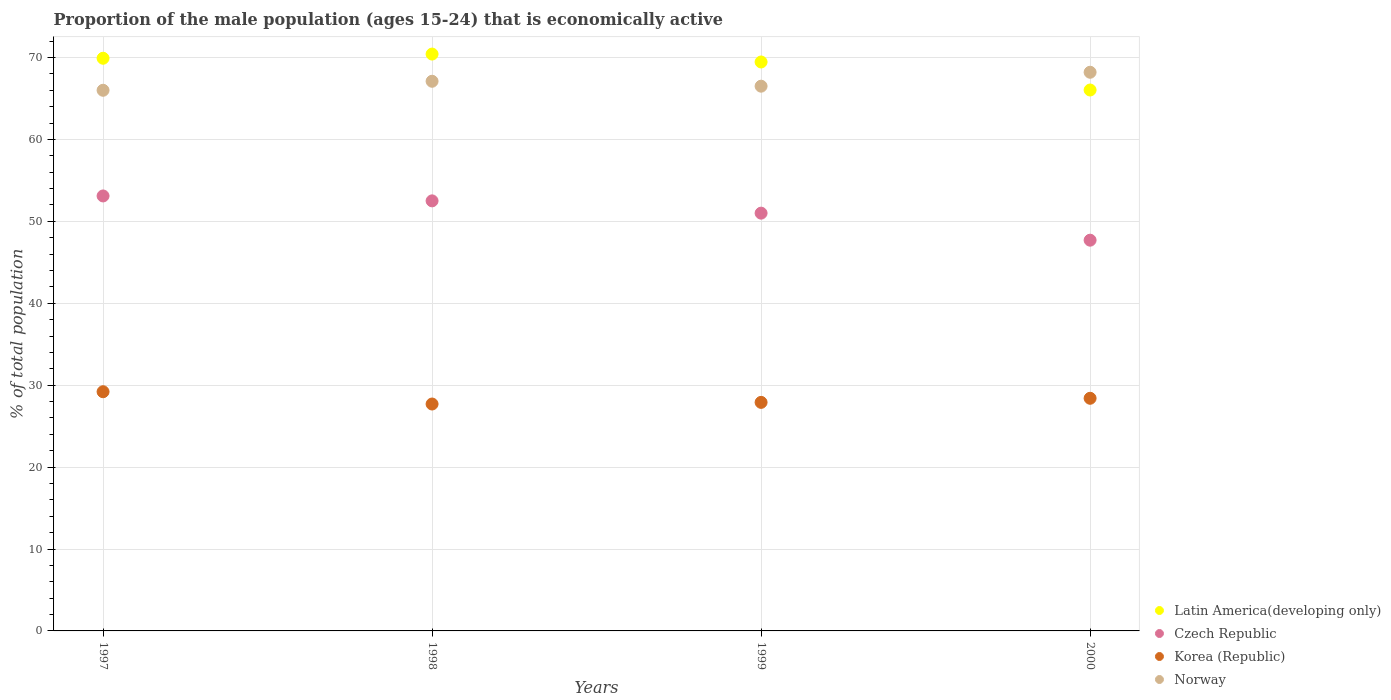What is the proportion of the male population that is economically active in Korea (Republic) in 1997?
Your response must be concise. 29.2. Across all years, what is the maximum proportion of the male population that is economically active in Latin America(developing only)?
Provide a succinct answer. 70.42. Across all years, what is the minimum proportion of the male population that is economically active in Latin America(developing only)?
Give a very brief answer. 66.03. What is the total proportion of the male population that is economically active in Norway in the graph?
Your answer should be compact. 267.8. What is the difference between the proportion of the male population that is economically active in Czech Republic in 1997 and that in 2000?
Ensure brevity in your answer.  5.4. What is the difference between the proportion of the male population that is economically active in Norway in 1998 and the proportion of the male population that is economically active in Latin America(developing only) in 1999?
Your response must be concise. -2.35. What is the average proportion of the male population that is economically active in Norway per year?
Your answer should be very brief. 66.95. In the year 2000, what is the difference between the proportion of the male population that is economically active in Czech Republic and proportion of the male population that is economically active in Latin America(developing only)?
Offer a terse response. -18.33. What is the ratio of the proportion of the male population that is economically active in Czech Republic in 1998 to that in 2000?
Keep it short and to the point. 1.1. What is the difference between the highest and the second highest proportion of the male population that is economically active in Korea (Republic)?
Your answer should be compact. 0.8. What is the difference between the highest and the lowest proportion of the male population that is economically active in Czech Republic?
Keep it short and to the point. 5.4. In how many years, is the proportion of the male population that is economically active in Czech Republic greater than the average proportion of the male population that is economically active in Czech Republic taken over all years?
Your answer should be compact. 2. Is it the case that in every year, the sum of the proportion of the male population that is economically active in Korea (Republic) and proportion of the male population that is economically active in Norway  is greater than the proportion of the male population that is economically active in Czech Republic?
Your response must be concise. Yes. Does the proportion of the male population that is economically active in Korea (Republic) monotonically increase over the years?
Give a very brief answer. No. How many dotlines are there?
Provide a succinct answer. 4. What is the difference between two consecutive major ticks on the Y-axis?
Ensure brevity in your answer.  10. Are the values on the major ticks of Y-axis written in scientific E-notation?
Make the answer very short. No. Does the graph contain grids?
Your answer should be compact. Yes. Where does the legend appear in the graph?
Offer a terse response. Bottom right. What is the title of the graph?
Make the answer very short. Proportion of the male population (ages 15-24) that is economically active. Does "United Arab Emirates" appear as one of the legend labels in the graph?
Your answer should be compact. No. What is the label or title of the Y-axis?
Your answer should be very brief. % of total population. What is the % of total population of Latin America(developing only) in 1997?
Provide a short and direct response. 69.91. What is the % of total population in Czech Republic in 1997?
Your answer should be compact. 53.1. What is the % of total population of Korea (Republic) in 1997?
Provide a short and direct response. 29.2. What is the % of total population in Norway in 1997?
Offer a very short reply. 66. What is the % of total population in Latin America(developing only) in 1998?
Ensure brevity in your answer.  70.42. What is the % of total population in Czech Republic in 1998?
Provide a short and direct response. 52.5. What is the % of total population in Korea (Republic) in 1998?
Keep it short and to the point. 27.7. What is the % of total population of Norway in 1998?
Make the answer very short. 67.1. What is the % of total population of Latin America(developing only) in 1999?
Your response must be concise. 69.45. What is the % of total population in Czech Republic in 1999?
Offer a terse response. 51. What is the % of total population of Korea (Republic) in 1999?
Give a very brief answer. 27.9. What is the % of total population in Norway in 1999?
Provide a short and direct response. 66.5. What is the % of total population of Latin America(developing only) in 2000?
Offer a very short reply. 66.03. What is the % of total population of Czech Republic in 2000?
Your answer should be compact. 47.7. What is the % of total population in Korea (Republic) in 2000?
Provide a short and direct response. 28.4. What is the % of total population in Norway in 2000?
Keep it short and to the point. 68.2. Across all years, what is the maximum % of total population of Latin America(developing only)?
Your response must be concise. 70.42. Across all years, what is the maximum % of total population in Czech Republic?
Your response must be concise. 53.1. Across all years, what is the maximum % of total population of Korea (Republic)?
Your response must be concise. 29.2. Across all years, what is the maximum % of total population in Norway?
Keep it short and to the point. 68.2. Across all years, what is the minimum % of total population of Latin America(developing only)?
Make the answer very short. 66.03. Across all years, what is the minimum % of total population in Czech Republic?
Make the answer very short. 47.7. Across all years, what is the minimum % of total population in Korea (Republic)?
Provide a short and direct response. 27.7. What is the total % of total population of Latin America(developing only) in the graph?
Offer a very short reply. 275.82. What is the total % of total population in Czech Republic in the graph?
Your answer should be compact. 204.3. What is the total % of total population in Korea (Republic) in the graph?
Ensure brevity in your answer.  113.2. What is the total % of total population of Norway in the graph?
Your response must be concise. 267.8. What is the difference between the % of total population of Latin America(developing only) in 1997 and that in 1998?
Your answer should be very brief. -0.51. What is the difference between the % of total population of Korea (Republic) in 1997 and that in 1998?
Your response must be concise. 1.5. What is the difference between the % of total population in Norway in 1997 and that in 1998?
Offer a terse response. -1.1. What is the difference between the % of total population of Latin America(developing only) in 1997 and that in 1999?
Ensure brevity in your answer.  0.46. What is the difference between the % of total population in Czech Republic in 1997 and that in 1999?
Make the answer very short. 2.1. What is the difference between the % of total population of Latin America(developing only) in 1997 and that in 2000?
Your answer should be very brief. 3.88. What is the difference between the % of total population in Korea (Republic) in 1997 and that in 2000?
Provide a short and direct response. 0.8. What is the difference between the % of total population of Norway in 1997 and that in 2000?
Offer a very short reply. -2.2. What is the difference between the % of total population in Latin America(developing only) in 1998 and that in 1999?
Your answer should be compact. 0.97. What is the difference between the % of total population of Czech Republic in 1998 and that in 1999?
Ensure brevity in your answer.  1.5. What is the difference between the % of total population of Latin America(developing only) in 1998 and that in 2000?
Your response must be concise. 4.39. What is the difference between the % of total population of Czech Republic in 1998 and that in 2000?
Provide a succinct answer. 4.8. What is the difference between the % of total population of Korea (Republic) in 1998 and that in 2000?
Provide a short and direct response. -0.7. What is the difference between the % of total population of Norway in 1998 and that in 2000?
Provide a short and direct response. -1.1. What is the difference between the % of total population in Latin America(developing only) in 1999 and that in 2000?
Provide a short and direct response. 3.42. What is the difference between the % of total population of Czech Republic in 1999 and that in 2000?
Keep it short and to the point. 3.3. What is the difference between the % of total population of Korea (Republic) in 1999 and that in 2000?
Provide a short and direct response. -0.5. What is the difference between the % of total population in Latin America(developing only) in 1997 and the % of total population in Czech Republic in 1998?
Give a very brief answer. 17.41. What is the difference between the % of total population of Latin America(developing only) in 1997 and the % of total population of Korea (Republic) in 1998?
Provide a succinct answer. 42.21. What is the difference between the % of total population of Latin America(developing only) in 1997 and the % of total population of Norway in 1998?
Make the answer very short. 2.81. What is the difference between the % of total population of Czech Republic in 1997 and the % of total population of Korea (Republic) in 1998?
Your response must be concise. 25.4. What is the difference between the % of total population of Korea (Republic) in 1997 and the % of total population of Norway in 1998?
Provide a succinct answer. -37.9. What is the difference between the % of total population of Latin America(developing only) in 1997 and the % of total population of Czech Republic in 1999?
Keep it short and to the point. 18.91. What is the difference between the % of total population in Latin America(developing only) in 1997 and the % of total population in Korea (Republic) in 1999?
Ensure brevity in your answer.  42.01. What is the difference between the % of total population in Latin America(developing only) in 1997 and the % of total population in Norway in 1999?
Make the answer very short. 3.41. What is the difference between the % of total population in Czech Republic in 1997 and the % of total population in Korea (Republic) in 1999?
Give a very brief answer. 25.2. What is the difference between the % of total population of Czech Republic in 1997 and the % of total population of Norway in 1999?
Your response must be concise. -13.4. What is the difference between the % of total population in Korea (Republic) in 1997 and the % of total population in Norway in 1999?
Provide a short and direct response. -37.3. What is the difference between the % of total population in Latin America(developing only) in 1997 and the % of total population in Czech Republic in 2000?
Make the answer very short. 22.21. What is the difference between the % of total population in Latin America(developing only) in 1997 and the % of total population in Korea (Republic) in 2000?
Ensure brevity in your answer.  41.51. What is the difference between the % of total population of Latin America(developing only) in 1997 and the % of total population of Norway in 2000?
Your answer should be compact. 1.71. What is the difference between the % of total population in Czech Republic in 1997 and the % of total population in Korea (Republic) in 2000?
Provide a short and direct response. 24.7. What is the difference between the % of total population in Czech Republic in 1997 and the % of total population in Norway in 2000?
Your response must be concise. -15.1. What is the difference between the % of total population in Korea (Republic) in 1997 and the % of total population in Norway in 2000?
Offer a very short reply. -39. What is the difference between the % of total population in Latin America(developing only) in 1998 and the % of total population in Czech Republic in 1999?
Your response must be concise. 19.42. What is the difference between the % of total population of Latin America(developing only) in 1998 and the % of total population of Korea (Republic) in 1999?
Your answer should be compact. 42.52. What is the difference between the % of total population in Latin America(developing only) in 1998 and the % of total population in Norway in 1999?
Keep it short and to the point. 3.92. What is the difference between the % of total population in Czech Republic in 1998 and the % of total population in Korea (Republic) in 1999?
Your answer should be very brief. 24.6. What is the difference between the % of total population of Czech Republic in 1998 and the % of total population of Norway in 1999?
Keep it short and to the point. -14. What is the difference between the % of total population of Korea (Republic) in 1998 and the % of total population of Norway in 1999?
Ensure brevity in your answer.  -38.8. What is the difference between the % of total population of Latin America(developing only) in 1998 and the % of total population of Czech Republic in 2000?
Provide a short and direct response. 22.72. What is the difference between the % of total population of Latin America(developing only) in 1998 and the % of total population of Korea (Republic) in 2000?
Give a very brief answer. 42.02. What is the difference between the % of total population in Latin America(developing only) in 1998 and the % of total population in Norway in 2000?
Offer a very short reply. 2.22. What is the difference between the % of total population of Czech Republic in 1998 and the % of total population of Korea (Republic) in 2000?
Your answer should be compact. 24.1. What is the difference between the % of total population in Czech Republic in 1998 and the % of total population in Norway in 2000?
Offer a very short reply. -15.7. What is the difference between the % of total population in Korea (Republic) in 1998 and the % of total population in Norway in 2000?
Offer a very short reply. -40.5. What is the difference between the % of total population of Latin America(developing only) in 1999 and the % of total population of Czech Republic in 2000?
Offer a very short reply. 21.75. What is the difference between the % of total population of Latin America(developing only) in 1999 and the % of total population of Korea (Republic) in 2000?
Provide a succinct answer. 41.05. What is the difference between the % of total population in Latin America(developing only) in 1999 and the % of total population in Norway in 2000?
Make the answer very short. 1.25. What is the difference between the % of total population in Czech Republic in 1999 and the % of total population in Korea (Republic) in 2000?
Your response must be concise. 22.6. What is the difference between the % of total population of Czech Republic in 1999 and the % of total population of Norway in 2000?
Ensure brevity in your answer.  -17.2. What is the difference between the % of total population in Korea (Republic) in 1999 and the % of total population in Norway in 2000?
Keep it short and to the point. -40.3. What is the average % of total population of Latin America(developing only) per year?
Make the answer very short. 68.95. What is the average % of total population in Czech Republic per year?
Your answer should be very brief. 51.08. What is the average % of total population in Korea (Republic) per year?
Offer a very short reply. 28.3. What is the average % of total population of Norway per year?
Provide a succinct answer. 66.95. In the year 1997, what is the difference between the % of total population in Latin America(developing only) and % of total population in Czech Republic?
Your answer should be very brief. 16.81. In the year 1997, what is the difference between the % of total population of Latin America(developing only) and % of total population of Korea (Republic)?
Your answer should be very brief. 40.71. In the year 1997, what is the difference between the % of total population in Latin America(developing only) and % of total population in Norway?
Provide a short and direct response. 3.91. In the year 1997, what is the difference between the % of total population of Czech Republic and % of total population of Korea (Republic)?
Offer a terse response. 23.9. In the year 1997, what is the difference between the % of total population of Korea (Republic) and % of total population of Norway?
Provide a succinct answer. -36.8. In the year 1998, what is the difference between the % of total population in Latin America(developing only) and % of total population in Czech Republic?
Give a very brief answer. 17.92. In the year 1998, what is the difference between the % of total population in Latin America(developing only) and % of total population in Korea (Republic)?
Offer a terse response. 42.72. In the year 1998, what is the difference between the % of total population in Latin America(developing only) and % of total population in Norway?
Offer a very short reply. 3.32. In the year 1998, what is the difference between the % of total population of Czech Republic and % of total population of Korea (Republic)?
Keep it short and to the point. 24.8. In the year 1998, what is the difference between the % of total population in Czech Republic and % of total population in Norway?
Your response must be concise. -14.6. In the year 1998, what is the difference between the % of total population of Korea (Republic) and % of total population of Norway?
Keep it short and to the point. -39.4. In the year 1999, what is the difference between the % of total population of Latin America(developing only) and % of total population of Czech Republic?
Make the answer very short. 18.45. In the year 1999, what is the difference between the % of total population of Latin America(developing only) and % of total population of Korea (Republic)?
Give a very brief answer. 41.55. In the year 1999, what is the difference between the % of total population in Latin America(developing only) and % of total population in Norway?
Your response must be concise. 2.95. In the year 1999, what is the difference between the % of total population of Czech Republic and % of total population of Korea (Republic)?
Provide a short and direct response. 23.1. In the year 1999, what is the difference between the % of total population of Czech Republic and % of total population of Norway?
Provide a short and direct response. -15.5. In the year 1999, what is the difference between the % of total population in Korea (Republic) and % of total population in Norway?
Your answer should be very brief. -38.6. In the year 2000, what is the difference between the % of total population in Latin America(developing only) and % of total population in Czech Republic?
Your response must be concise. 18.33. In the year 2000, what is the difference between the % of total population in Latin America(developing only) and % of total population in Korea (Republic)?
Your response must be concise. 37.63. In the year 2000, what is the difference between the % of total population in Latin America(developing only) and % of total population in Norway?
Give a very brief answer. -2.17. In the year 2000, what is the difference between the % of total population of Czech Republic and % of total population of Korea (Republic)?
Your response must be concise. 19.3. In the year 2000, what is the difference between the % of total population of Czech Republic and % of total population of Norway?
Your answer should be compact. -20.5. In the year 2000, what is the difference between the % of total population in Korea (Republic) and % of total population in Norway?
Your answer should be very brief. -39.8. What is the ratio of the % of total population of Latin America(developing only) in 1997 to that in 1998?
Ensure brevity in your answer.  0.99. What is the ratio of the % of total population of Czech Republic in 1997 to that in 1998?
Offer a terse response. 1.01. What is the ratio of the % of total population in Korea (Republic) in 1997 to that in 1998?
Your answer should be very brief. 1.05. What is the ratio of the % of total population in Norway in 1997 to that in 1998?
Your answer should be compact. 0.98. What is the ratio of the % of total population in Latin America(developing only) in 1997 to that in 1999?
Provide a succinct answer. 1.01. What is the ratio of the % of total population of Czech Republic in 1997 to that in 1999?
Your answer should be very brief. 1.04. What is the ratio of the % of total population in Korea (Republic) in 1997 to that in 1999?
Keep it short and to the point. 1.05. What is the ratio of the % of total population of Latin America(developing only) in 1997 to that in 2000?
Provide a short and direct response. 1.06. What is the ratio of the % of total population in Czech Republic in 1997 to that in 2000?
Your answer should be compact. 1.11. What is the ratio of the % of total population in Korea (Republic) in 1997 to that in 2000?
Ensure brevity in your answer.  1.03. What is the ratio of the % of total population in Norway in 1997 to that in 2000?
Provide a short and direct response. 0.97. What is the ratio of the % of total population in Latin America(developing only) in 1998 to that in 1999?
Keep it short and to the point. 1.01. What is the ratio of the % of total population in Czech Republic in 1998 to that in 1999?
Offer a terse response. 1.03. What is the ratio of the % of total population of Korea (Republic) in 1998 to that in 1999?
Provide a short and direct response. 0.99. What is the ratio of the % of total population in Norway in 1998 to that in 1999?
Keep it short and to the point. 1.01. What is the ratio of the % of total population of Latin America(developing only) in 1998 to that in 2000?
Provide a short and direct response. 1.07. What is the ratio of the % of total population of Czech Republic in 1998 to that in 2000?
Your answer should be very brief. 1.1. What is the ratio of the % of total population in Korea (Republic) in 1998 to that in 2000?
Provide a succinct answer. 0.98. What is the ratio of the % of total population of Norway in 1998 to that in 2000?
Offer a very short reply. 0.98. What is the ratio of the % of total population of Latin America(developing only) in 1999 to that in 2000?
Ensure brevity in your answer.  1.05. What is the ratio of the % of total population of Czech Republic in 1999 to that in 2000?
Your response must be concise. 1.07. What is the ratio of the % of total population of Korea (Republic) in 1999 to that in 2000?
Keep it short and to the point. 0.98. What is the ratio of the % of total population of Norway in 1999 to that in 2000?
Ensure brevity in your answer.  0.98. What is the difference between the highest and the second highest % of total population in Latin America(developing only)?
Your answer should be compact. 0.51. What is the difference between the highest and the lowest % of total population of Latin America(developing only)?
Make the answer very short. 4.39. What is the difference between the highest and the lowest % of total population in Czech Republic?
Keep it short and to the point. 5.4. What is the difference between the highest and the lowest % of total population of Norway?
Your answer should be compact. 2.2. 